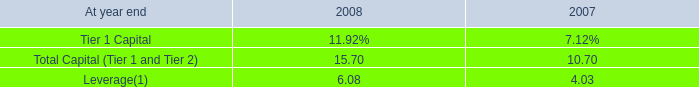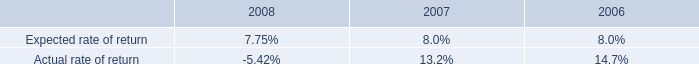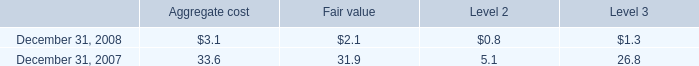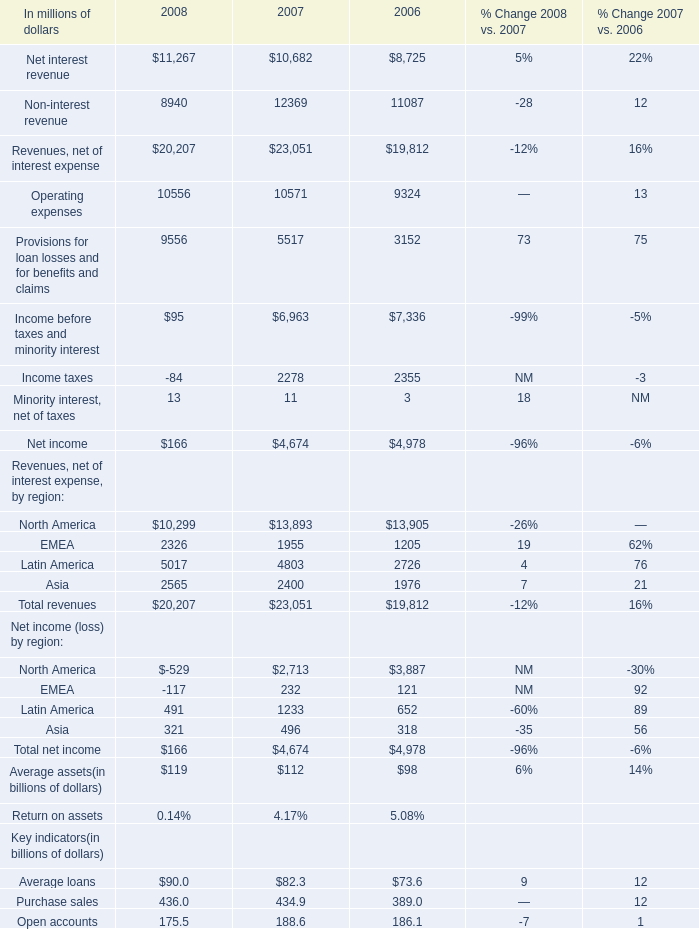What was the average of Net income in 2006,2007 and 2008? (in million) 
Computations: (((166 + 4674) + 4978) / 3)
Answer: 3272.66667. 